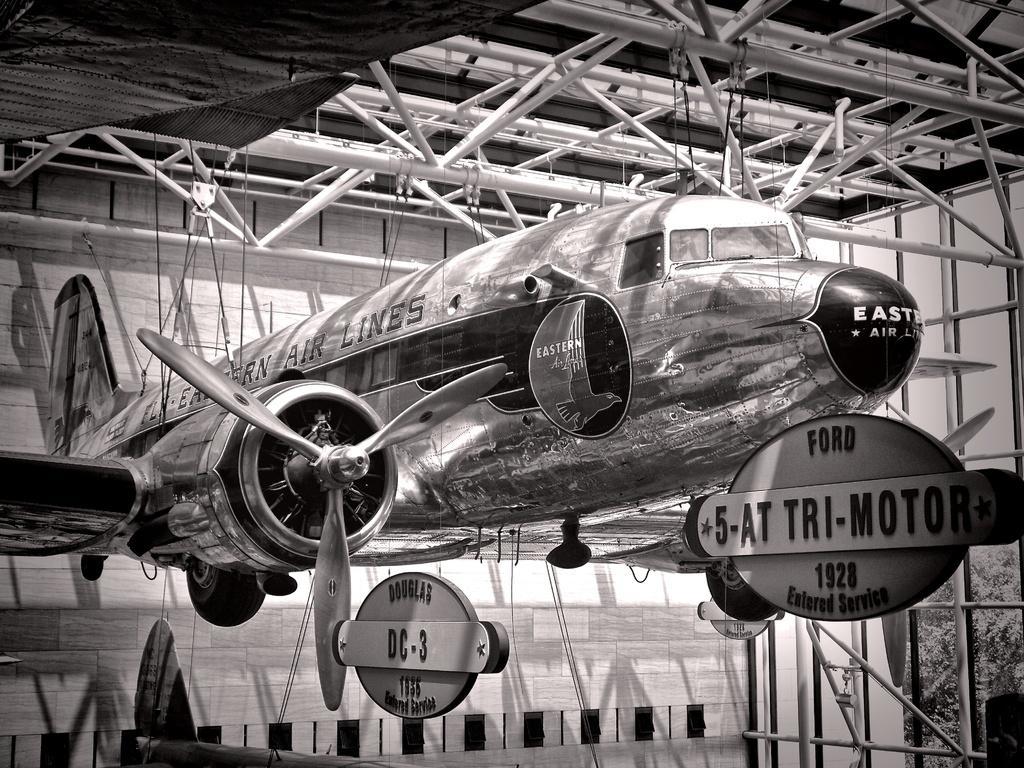Describe this image in one or two sentences. This is a black and white image, in this image there is an aircraft hanged to the iron roads, in the background there is a wall and there are board on that boards there is text. 